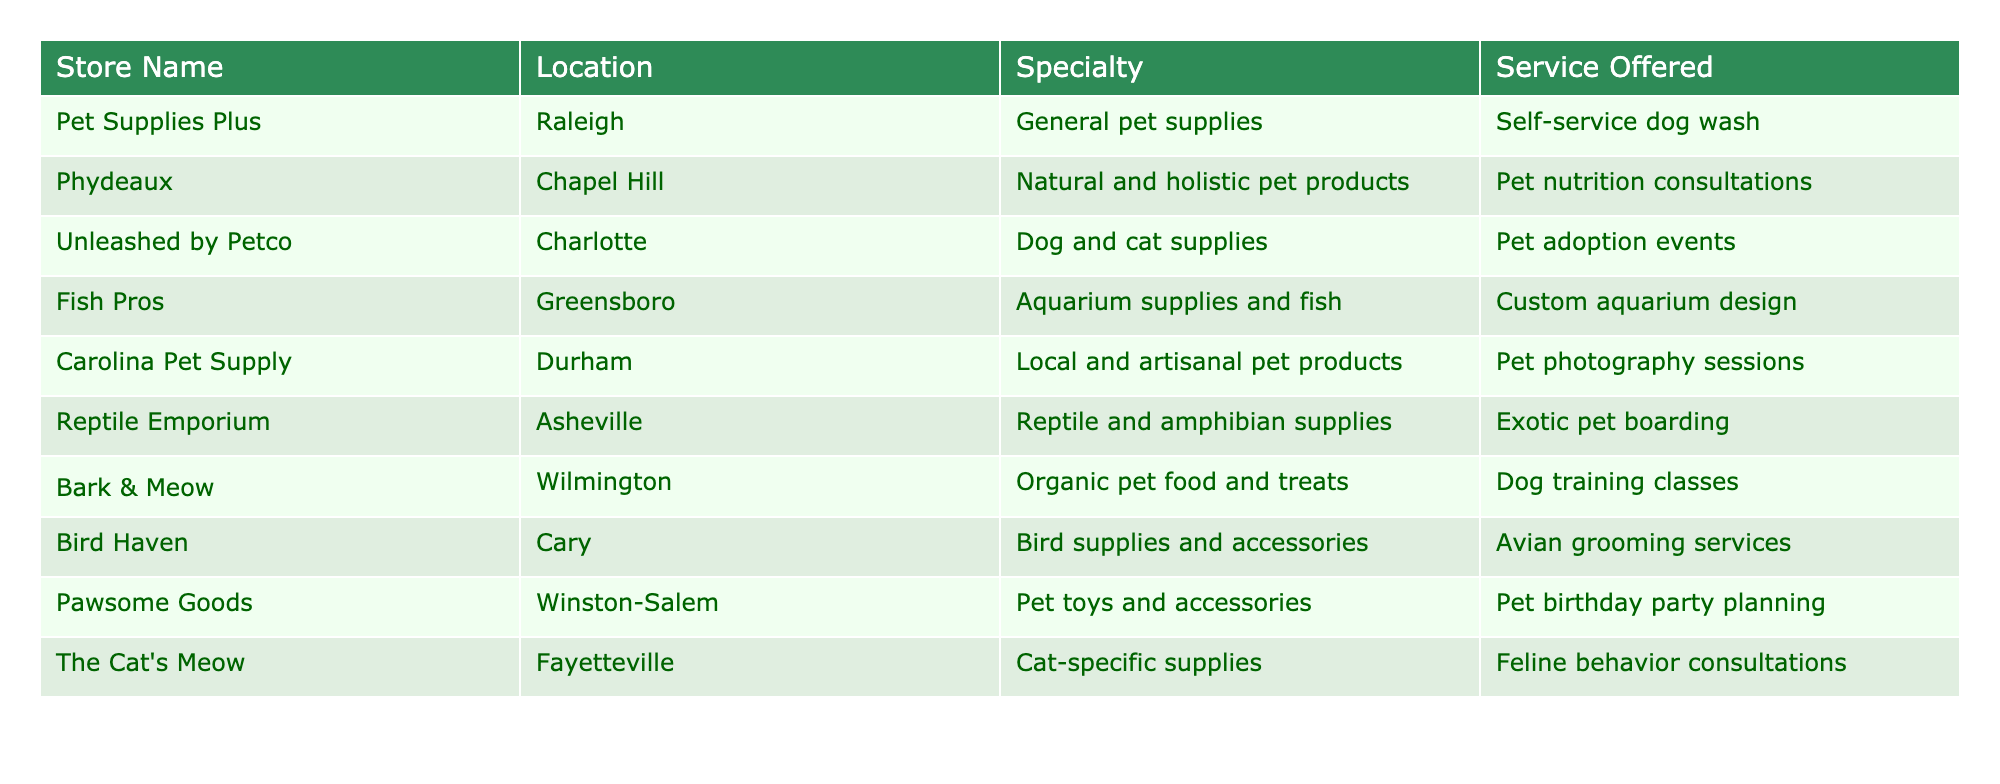What is the specialty of Fish Pros? The table lists the specialties for each store. Fish Pros, located in Greensboro, specializes in aquarium supplies and fish.
Answer: Aquarium supplies and fish Which store in Chapel Hill offers pet nutrition consultations? The table shows that Phydeaux, located in Chapel Hill, offers natural and holistic pet products along with pet nutrition consultations.
Answer: Phydeaux How many stores offer services related to dog training or behavior consultations? From the table, I will count the stores that either offer dog training classes or feline behavior consultations. Bark & Meow offers dog training classes, and The Cat's Meow offers feline behavior consultations. Therefore, there are two stores.
Answer: 2 Does Carolina Pet Supply provide pet photography sessions? By checking the services offered by Carolina Pet Supply in the table, I can confirm that they do provide pet photography sessions as part of their services.
Answer: Yes Which store specializes in reptile and amphibian supplies, and what service do they offer? The store that specializes in reptile and amphibian supplies is Reptile Emporium in Asheville, and it offers exotic pet boarding as a service.
Answer: Reptile Emporium; Exotic pet boarding What is the average number of specialties offered by the stores listed? I will first identify the number of unique specialties provided by each store. Summarizing the specials: General pet supplies, Natural and holistic pet products, Dog and cat supplies, Aquarium supplies and fish, Local and artisanal pet products, Reptile and amphibian supplies, Organic pet food and treats, Bird supplies and accessories, Pet toys and accessories, Cat-specific supplies — that gives us ten specialties. There are a total of 10 stores, so the average is 10/10 = 1.
Answer: 1 Is there a store in Fayetteville that offers supplies specifically for cats? The table indicates that The Cat's Meow, located in Fayetteville, indeed specializes in cat-specific supplies. Therefore, the answer is yes.
Answer: Yes Which two stores are located in cities starting with the letter 'R'? The two stores from the table located in cities starting with 'R' are Pet Supplies Plus in Raleigh and Bark & Meow in Wilmington, with Raleigh being the only store that directly starts with 'R'. So, I also notice that there is no second store in a different city with 'R'. The correct insight is that there is one store that fits this description.
Answer: 1 How does the range of services differ between stores focused on bird supplies and those focused on dog supplies? Bird Haven, specializing in bird supplies, offers avian grooming services, while Bark & Meow, specializing in dog supplies, provides dog training classes. The difference here is that bird services focus on grooming, whereas dog services focus on training.
Answer: Grooming vs. Training 